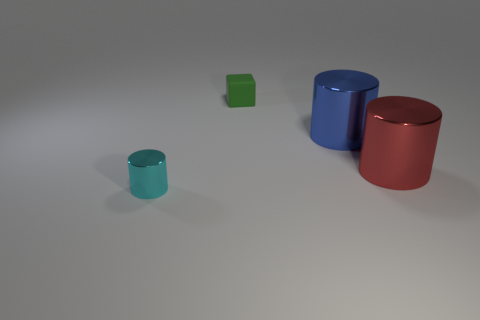Judging by the image, what do you think is the mood or theme of this setup? The image evokes a sense of simplicity and minimalism, using a limited color palette and a clean composition. The play of light and shadow adds a tranquil mood to the setting. 